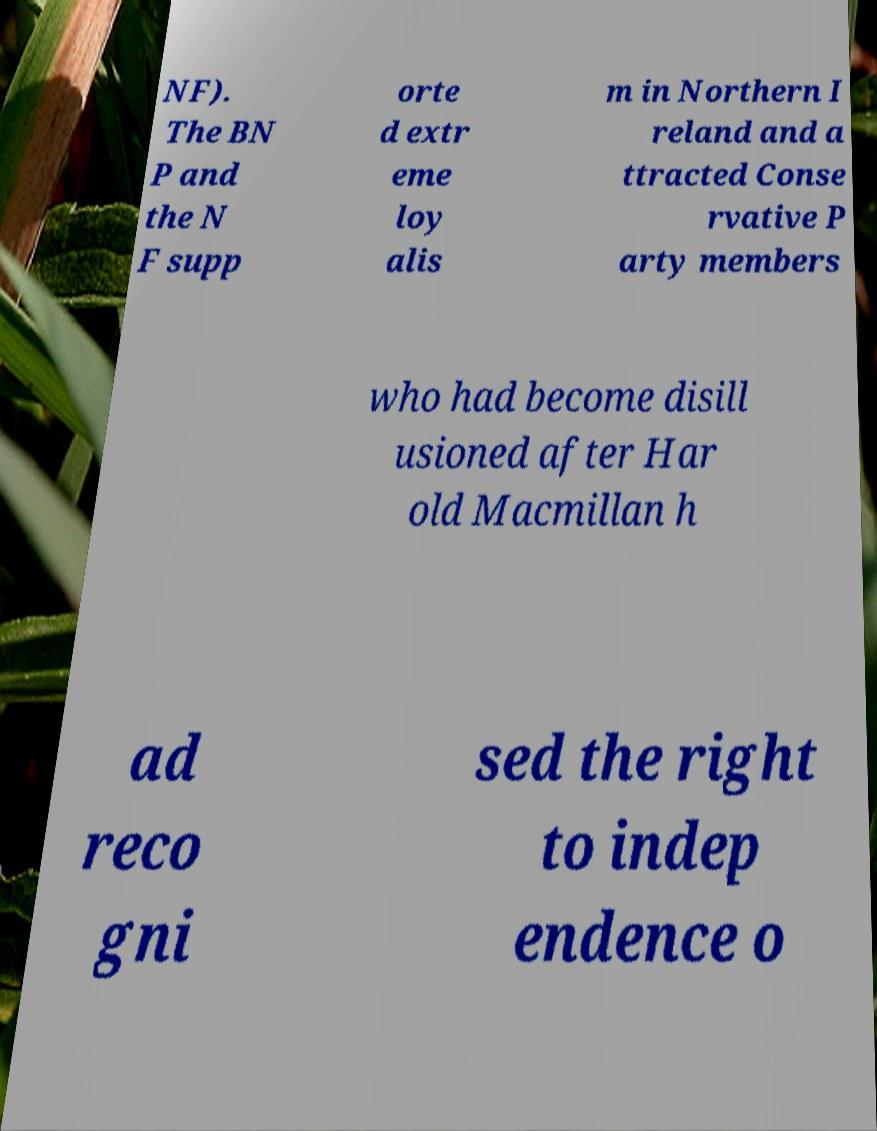Please read and relay the text visible in this image. What does it say? NF). The BN P and the N F supp orte d extr eme loy alis m in Northern I reland and a ttracted Conse rvative P arty members who had become disill usioned after Har old Macmillan h ad reco gni sed the right to indep endence o 